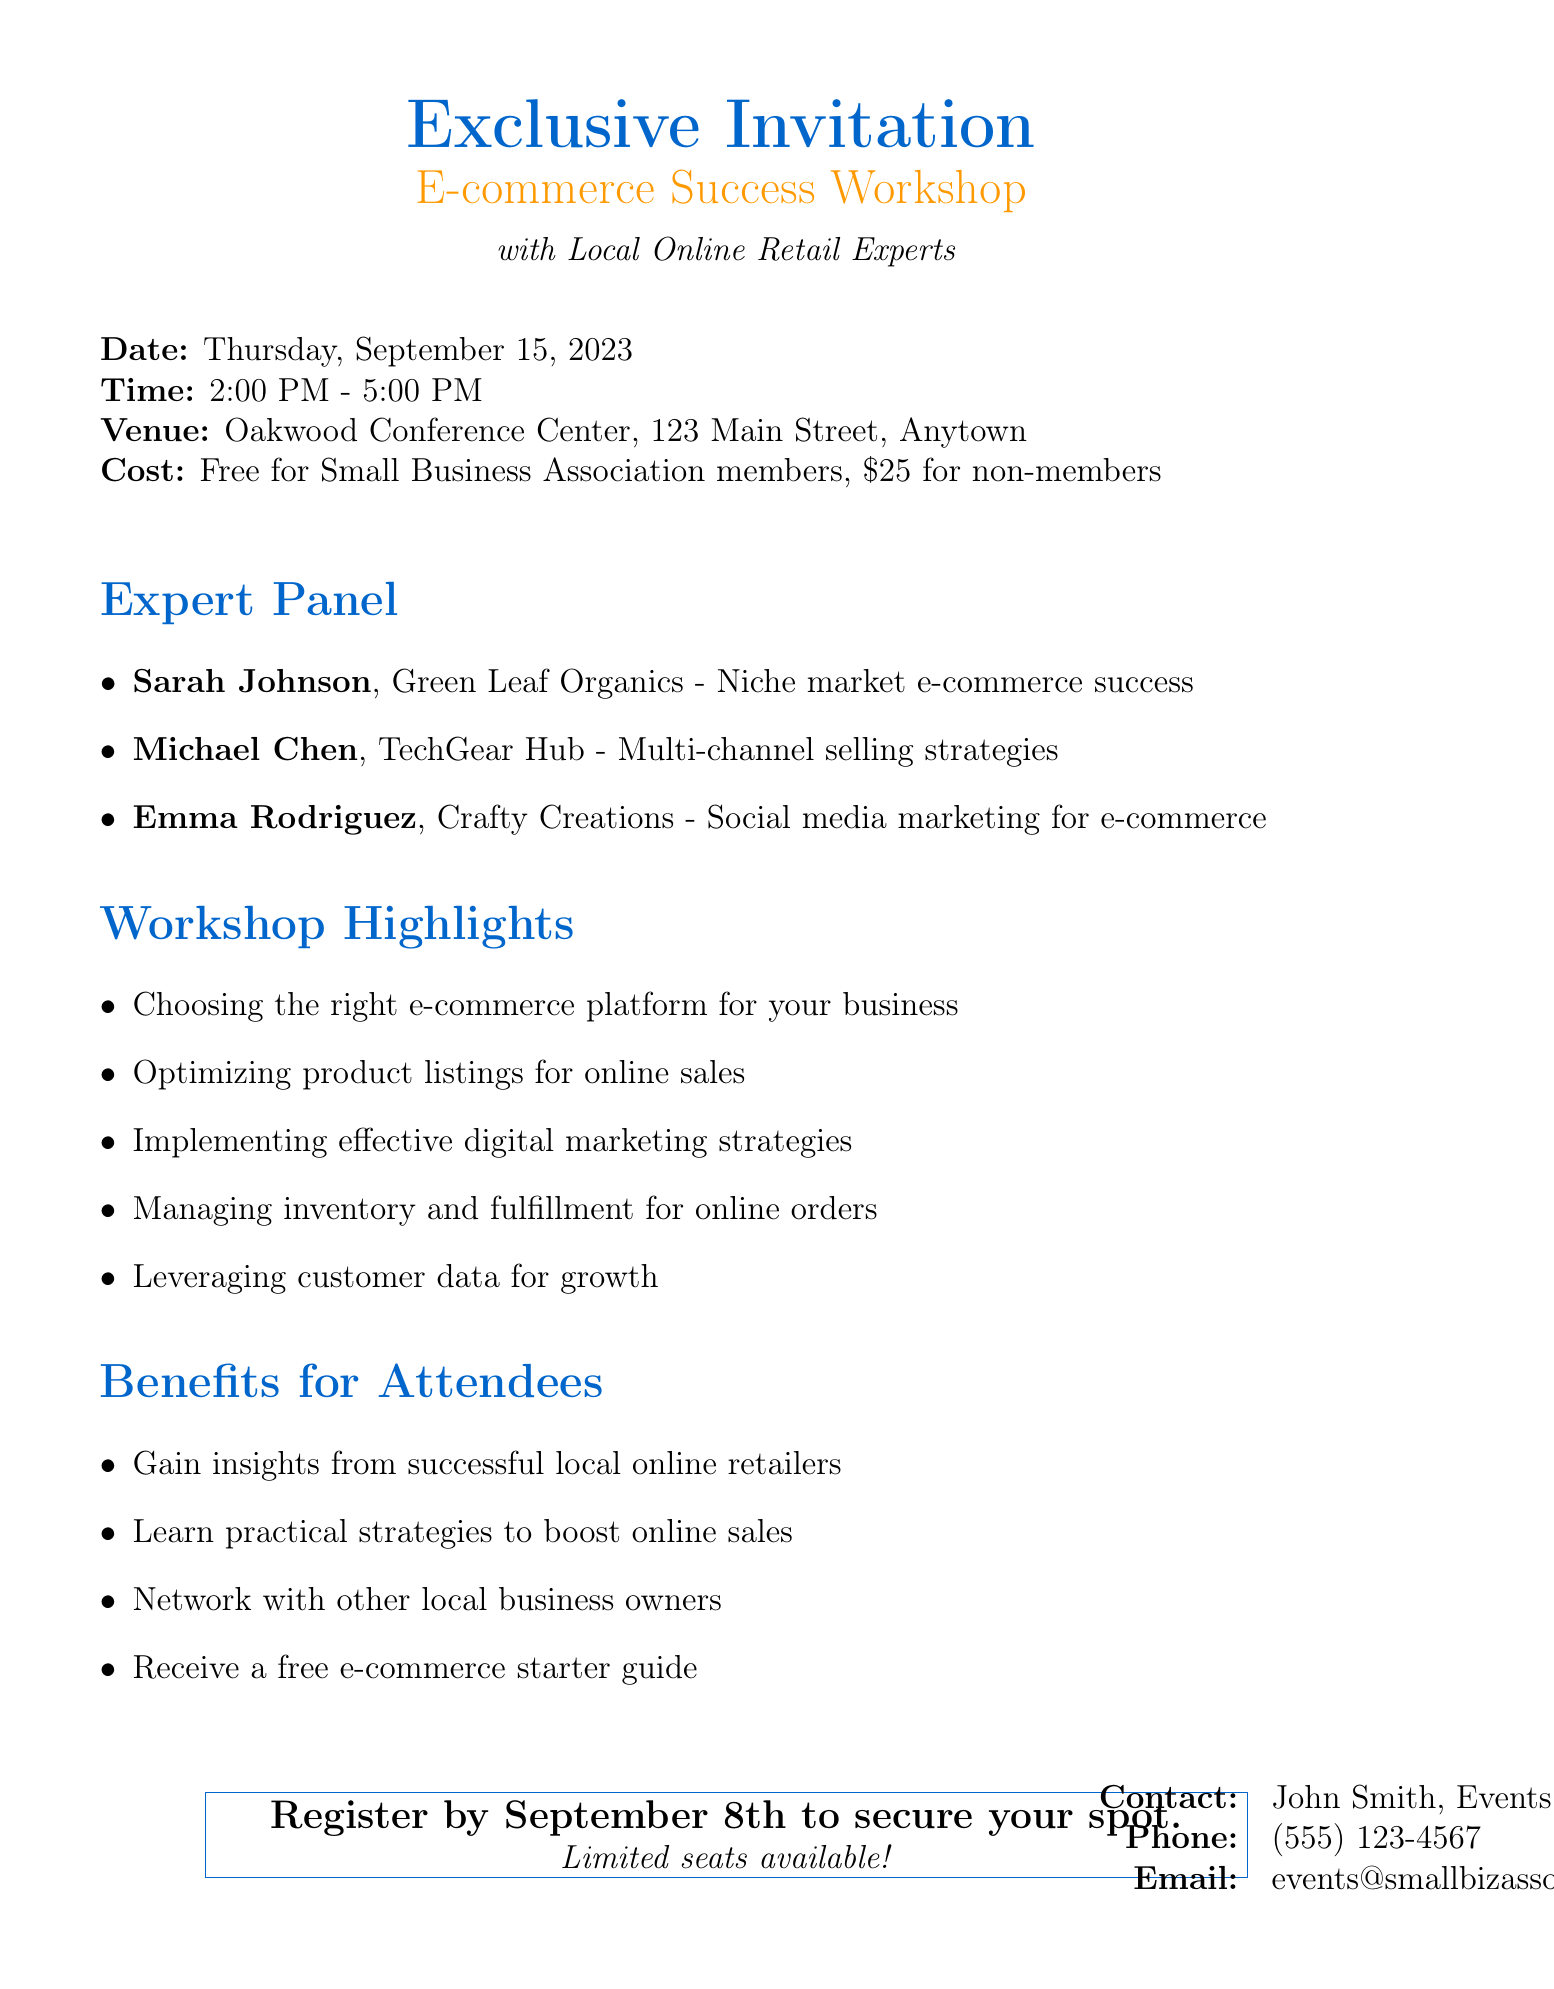What is the date of the workshop? The date of the workshop is clearly stated in the event details section of the document.
Answer: Thursday, September 15, 2023 Who is the contact person for the workshop? The contact person is mentioned at the bottom of the document under the contact information section.
Answer: John Smith What is the cost for non-members to attend? The cost for non-members is specified in the event details section of the document.
Answer: $25 What is one of the workshop highlights? The workshop highlights are listed, and any item from that list can be selected as an answer.
Answer: Choosing the right e-commerce platform for your business How long will the workshop last? The duration of the workshop can be found in the event details, which includes the start and end times.
Answer: 3 hours What benefit do attendees receive? The benefits for attendees are outlined, and one of the items can be chosen as a response.
Answer: Receive a free e-commerce starter guide Who is featured on the panel with expertise in social media marketing? The panel members are listed along with their areas of expertise, allowing for identification of the relevant person.
Answer: Emma Rodriguez What is the last date to register? The deadline for registration is mentioned in the call to action at the end of the document.
Answer: September 8th Where is the venue located? The venue address is stated directly in the event details.
Answer: Oakwood Conference Center, 123 Main Street, Anytown 